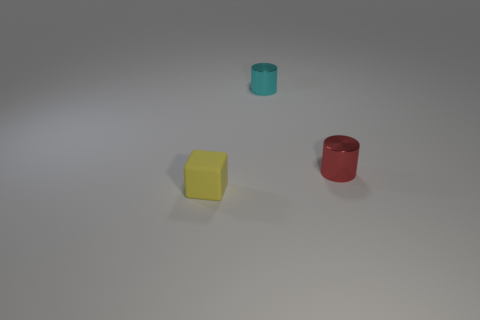There is a thing that is to the left of the tiny shiny cylinder that is behind the tiny red metallic cylinder; what is its color?
Provide a succinct answer. Yellow. There is a thing that is behind the small red metallic object; what is its material?
Offer a very short reply. Metal. Are there fewer tiny red cylinders than green balls?
Provide a short and direct response. No. There is a cyan metal object; is it the same shape as the small yellow matte object in front of the red shiny object?
Give a very brief answer. No. What is the shape of the object that is both in front of the cyan thing and to the left of the tiny red metal object?
Provide a succinct answer. Cube. Are there the same number of tiny cyan metal objects that are in front of the matte object and small metallic things in front of the small red metal cylinder?
Make the answer very short. Yes. Do the thing to the left of the tiny cyan object and the cyan metallic object have the same shape?
Offer a very short reply. No. How many cyan objects are either small metallic cylinders or matte cubes?
Offer a terse response. 1. What is the material of the tiny red object that is the same shape as the tiny cyan shiny object?
Provide a succinct answer. Metal. What shape is the metallic thing in front of the tiny cyan metallic thing?
Offer a very short reply. Cylinder. 